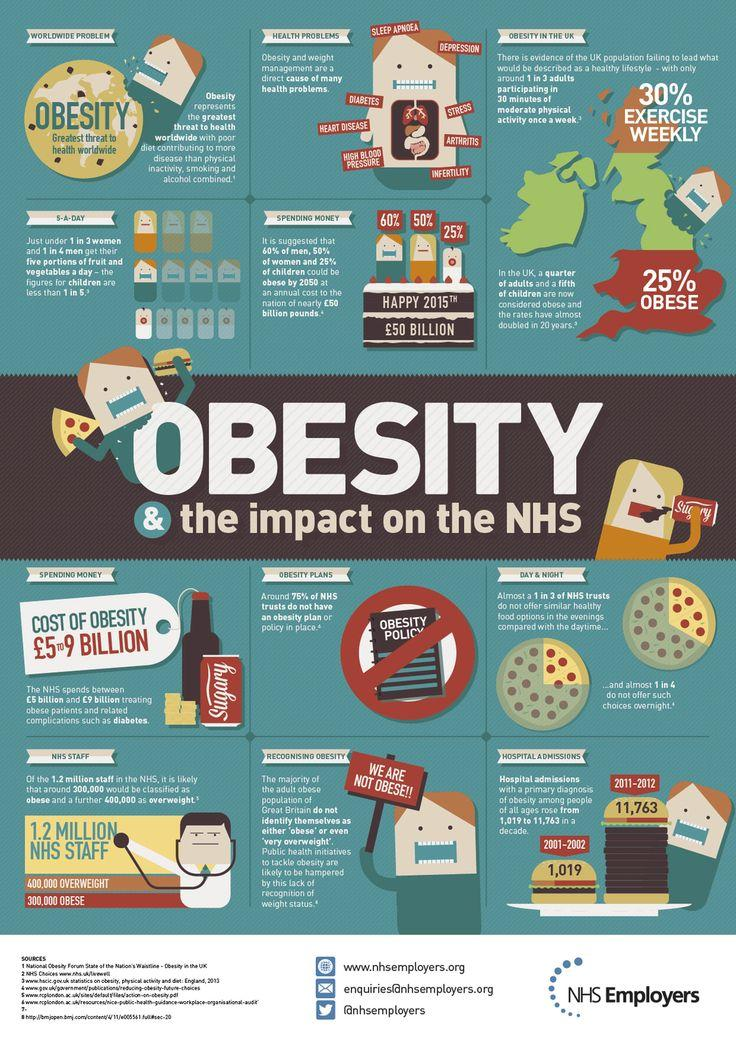Give some essential details in this illustration. From the year 2001 to 2012, there was a significant increase in the number of obesity patients, with a total increase of 10,744 patients. By 2050, it is projected that children will be the least obese category of people among men, women, and children. According to NHS data, approximately 25% of NHS organisations have an obesity plan in place. 